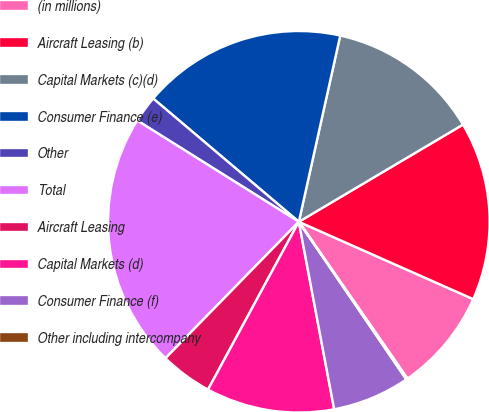Convert chart to OTSL. <chart><loc_0><loc_0><loc_500><loc_500><pie_chart><fcel>(in millions)<fcel>Aircraft Leasing (b)<fcel>Capital Markets (c)(d)<fcel>Consumer Finance (e)<fcel>Other<fcel>Total<fcel>Aircraft Leasing<fcel>Capital Markets (d)<fcel>Consumer Finance (f)<fcel>Other including intercompany<nl><fcel>8.71%<fcel>15.15%<fcel>13.01%<fcel>17.3%<fcel>2.27%<fcel>21.59%<fcel>4.42%<fcel>10.86%<fcel>6.56%<fcel>0.12%<nl></chart> 